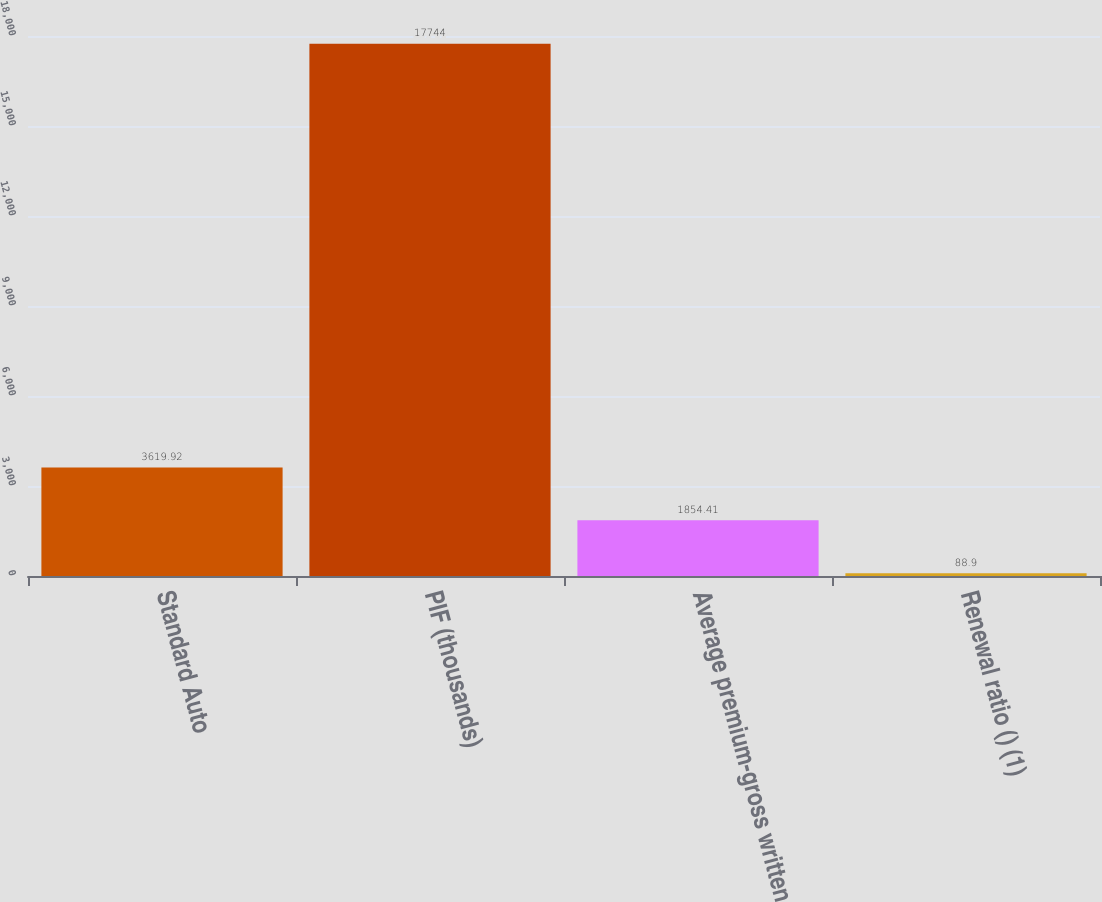Convert chart to OTSL. <chart><loc_0><loc_0><loc_500><loc_500><bar_chart><fcel>Standard Auto<fcel>PIF (thousands)<fcel>Average premium-gross written<fcel>Renewal ratio () (1)<nl><fcel>3619.92<fcel>17744<fcel>1854.41<fcel>88.9<nl></chart> 